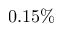Convert formula to latex. <formula><loc_0><loc_0><loc_500><loc_500>0 . 1 5 \%</formula> 